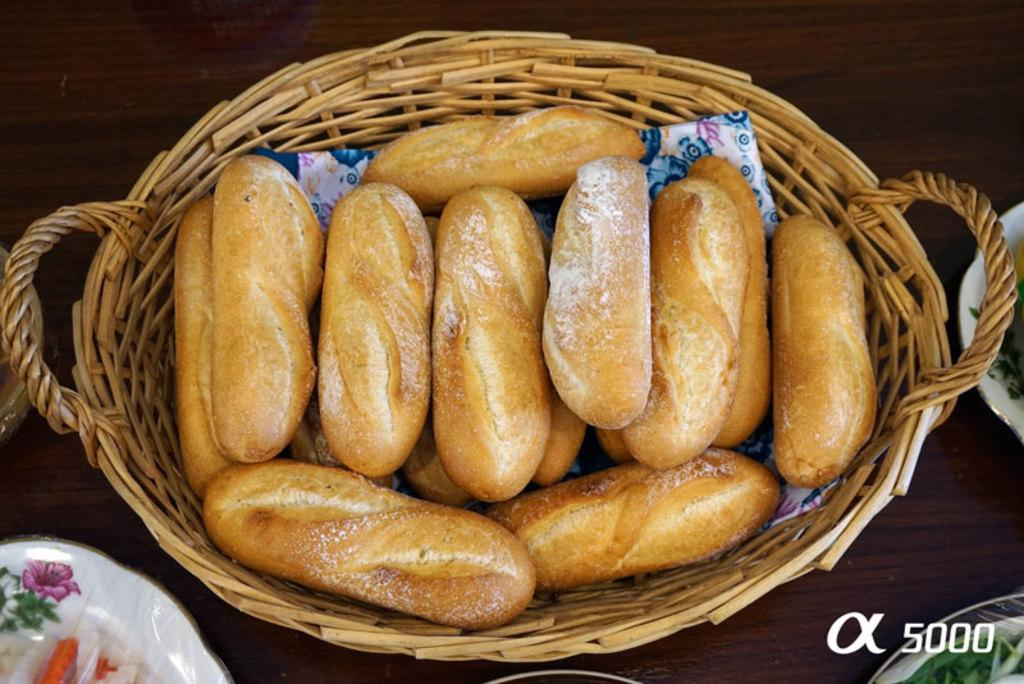What can be found in the left corner of the image? There are objects in the left corner of the image. What can be found in the right corner of the image? There are objects in the right corner of the image. What is located in the foreground of the image? There is a basket with food in the foreground of the image. How would you describe the background of the image? The background of the image is colored. What type of class is being held in the image? There is no class present in the image. Is there a battle taking place in the image? There is no battle present in the image. 